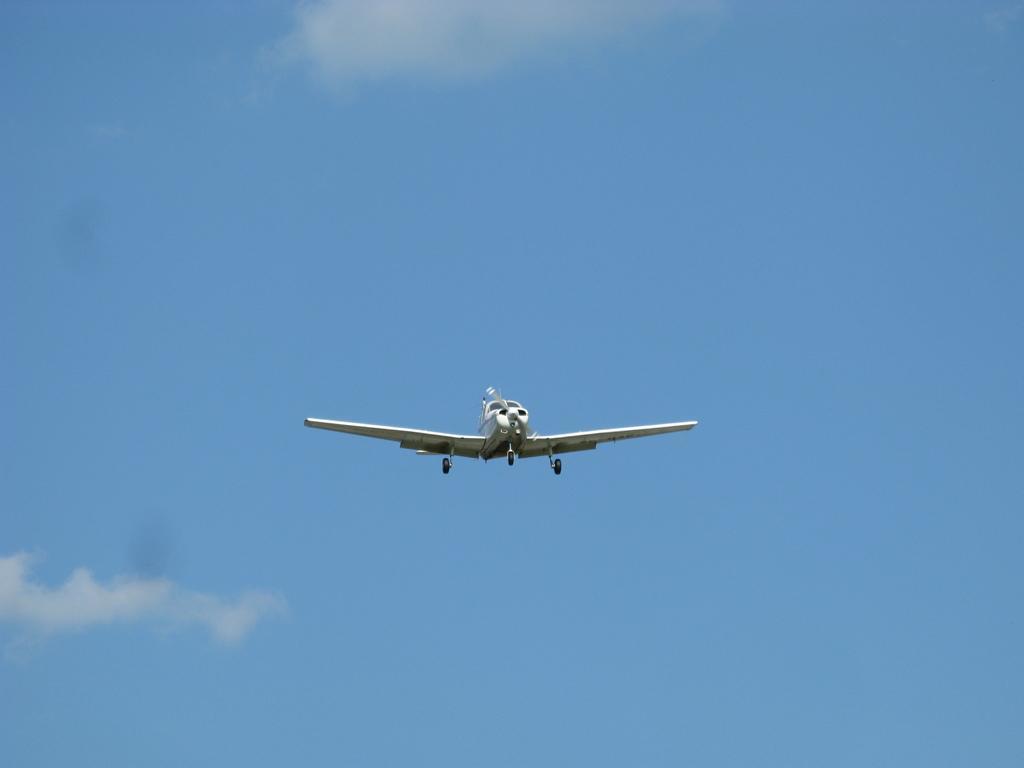How would you summarize this image in a sentence or two? In this image, in the middle, we can see an airplane which is flying in the air. In the background, we can see a sky which is a bit cloudy. 